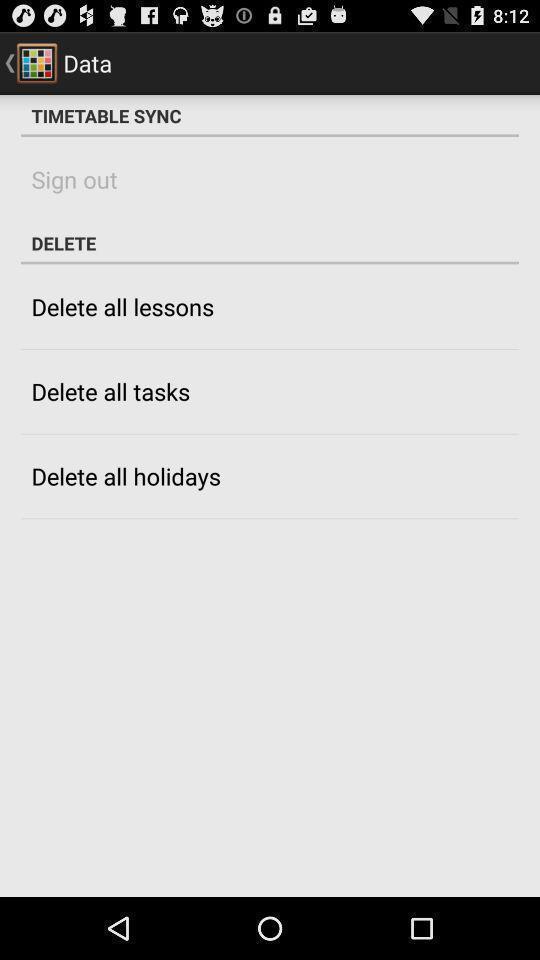Provide a textual representation of this image. Page shows the options in a timetable application. 